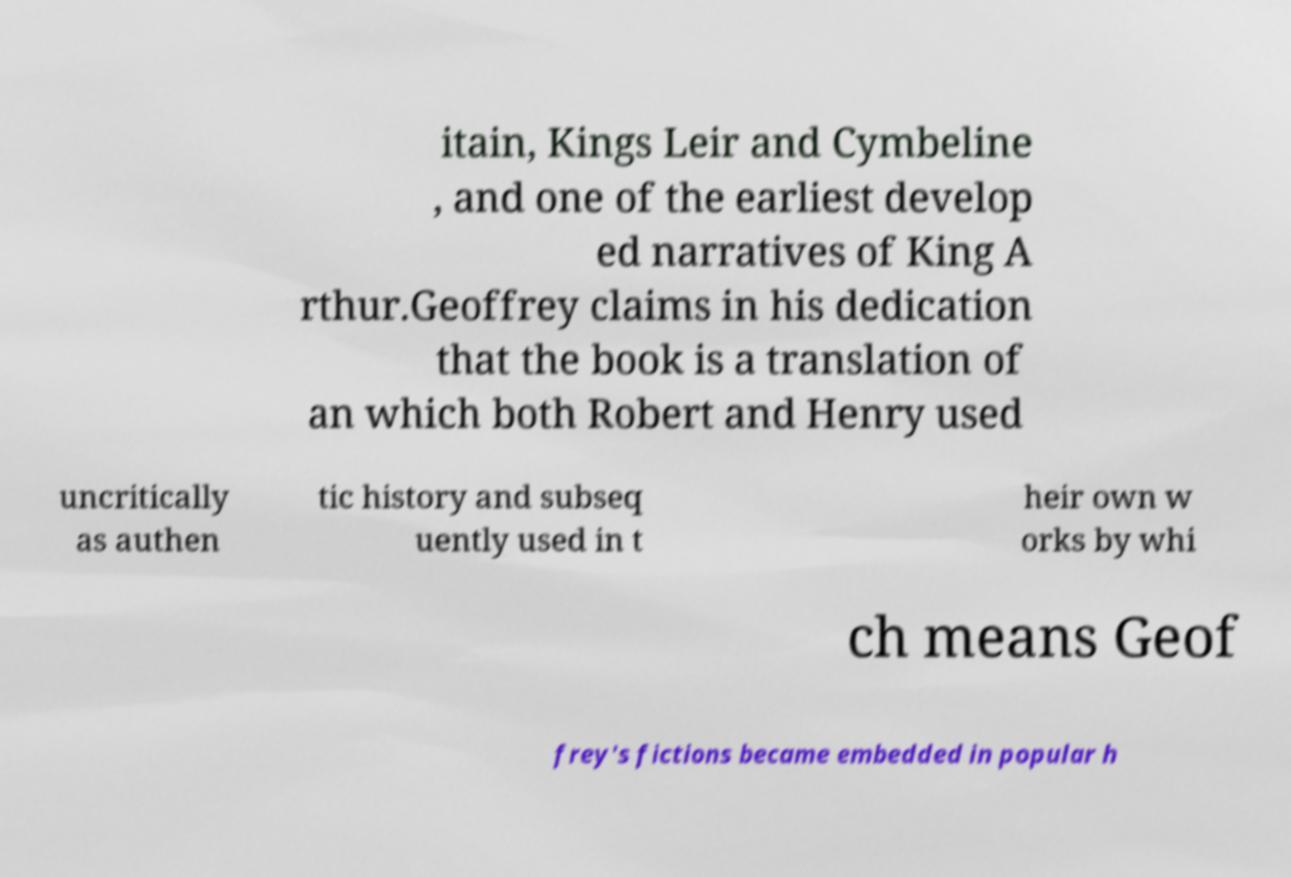Can you read and provide the text displayed in the image?This photo seems to have some interesting text. Can you extract and type it out for me? itain, Kings Leir and Cymbeline , and one of the earliest develop ed narratives of King A rthur.Geoffrey claims in his dedication that the book is a translation of an which both Robert and Henry used uncritically as authen tic history and subseq uently used in t heir own w orks by whi ch means Geof frey's fictions became embedded in popular h 